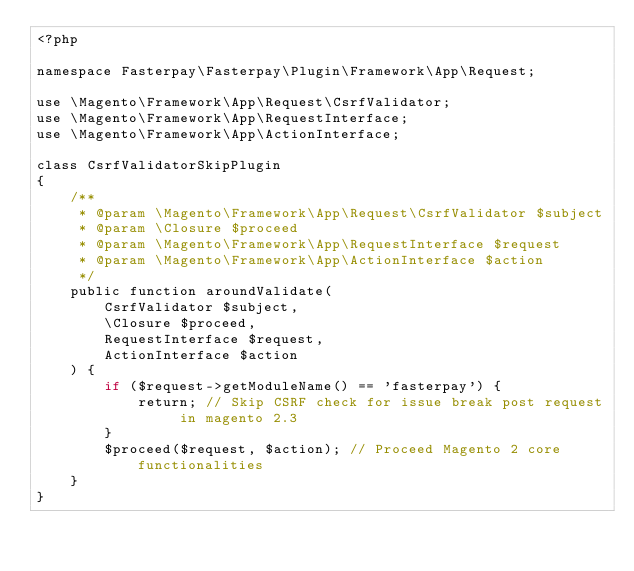<code> <loc_0><loc_0><loc_500><loc_500><_PHP_><?php

namespace Fasterpay\Fasterpay\Plugin\Framework\App\Request;

use \Magento\Framework\App\Request\CsrfValidator;
use \Magento\Framework\App\RequestInterface;
use \Magento\Framework\App\ActionInterface;

class CsrfValidatorSkipPlugin
{
    /**
     * @param \Magento\Framework\App\Request\CsrfValidator $subject
     * @param \Closure $proceed
     * @param \Magento\Framework\App\RequestInterface $request
     * @param \Magento\Framework\App\ActionInterface $action
     */
    public function aroundValidate(
        CsrfValidator $subject,
        \Closure $proceed,
        RequestInterface $request,
        ActionInterface $action
    ) {
        if ($request->getModuleName() == 'fasterpay') {
            return; // Skip CSRF check for issue break post request in magento 2.3
        }
        $proceed($request, $action); // Proceed Magento 2 core functionalities
    }
}</code> 